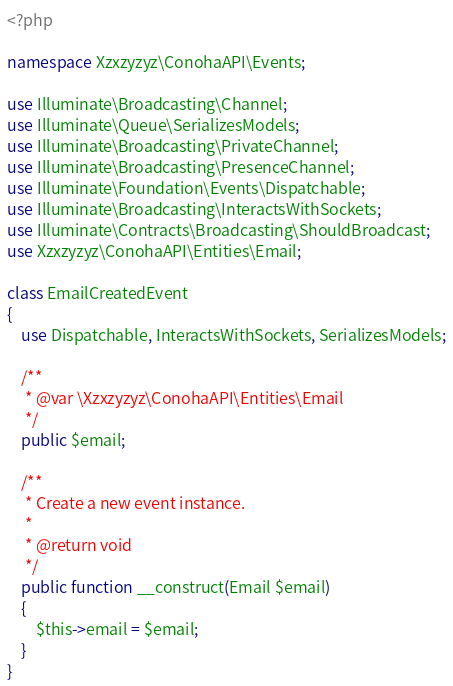Convert code to text. <code><loc_0><loc_0><loc_500><loc_500><_PHP_><?php

namespace Xzxzyzyz\ConohaAPI\Events;

use Illuminate\Broadcasting\Channel;
use Illuminate\Queue\SerializesModels;
use Illuminate\Broadcasting\PrivateChannel;
use Illuminate\Broadcasting\PresenceChannel;
use Illuminate\Foundation\Events\Dispatchable;
use Illuminate\Broadcasting\InteractsWithSockets;
use Illuminate\Contracts\Broadcasting\ShouldBroadcast;
use Xzxzyzyz\ConohaAPI\Entities\Email;

class EmailCreatedEvent
{
    use Dispatchable, InteractsWithSockets, SerializesModels;

    /**
     * @var \Xzxzyzyz\ConohaAPI\Entities\Email
     */
    public $email;

    /**
     * Create a new event instance.
     *
     * @return void
     */
    public function __construct(Email $email)
    {
        $this->email = $email;
    }
}
</code> 